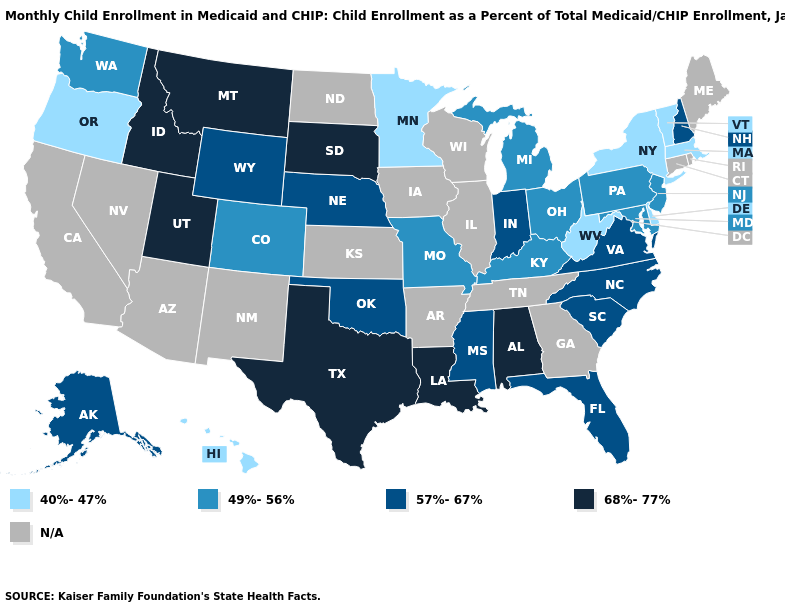What is the highest value in the Northeast ?
Keep it brief. 57%-67%. What is the value of North Dakota?
Be succinct. N/A. What is the highest value in states that border Missouri?
Give a very brief answer. 57%-67%. Does Texas have the highest value in the USA?
Be succinct. Yes. Which states have the lowest value in the USA?
Keep it brief. Delaware, Hawaii, Massachusetts, Minnesota, New York, Oregon, Vermont, West Virginia. What is the value of Montana?
Answer briefly. 68%-77%. Name the states that have a value in the range 57%-67%?
Give a very brief answer. Alaska, Florida, Indiana, Mississippi, Nebraska, New Hampshire, North Carolina, Oklahoma, South Carolina, Virginia, Wyoming. Which states have the lowest value in the USA?
Answer briefly. Delaware, Hawaii, Massachusetts, Minnesota, New York, Oregon, Vermont, West Virginia. Among the states that border New York , does New Jersey have the lowest value?
Concise answer only. No. Name the states that have a value in the range 57%-67%?
Answer briefly. Alaska, Florida, Indiana, Mississippi, Nebraska, New Hampshire, North Carolina, Oklahoma, South Carolina, Virginia, Wyoming. Name the states that have a value in the range 40%-47%?
Be succinct. Delaware, Hawaii, Massachusetts, Minnesota, New York, Oregon, Vermont, West Virginia. What is the value of Arkansas?
Quick response, please. N/A. 